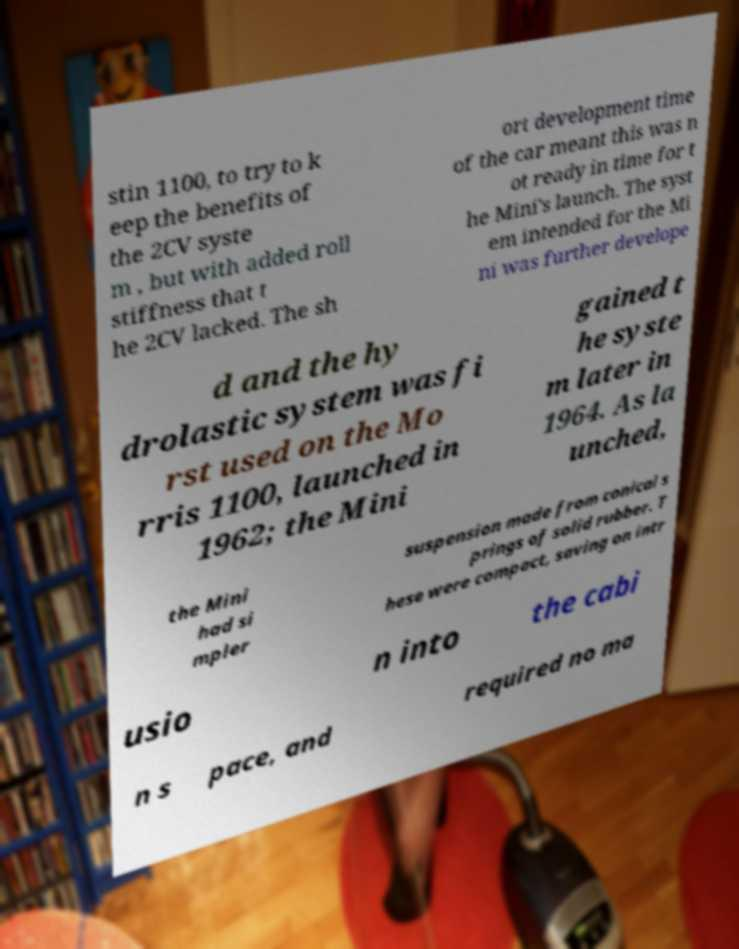There's text embedded in this image that I need extracted. Can you transcribe it verbatim? stin 1100, to try to k eep the benefits of the 2CV syste m , but with added roll stiffness that t he 2CV lacked. The sh ort development time of the car meant this was n ot ready in time for t he Mini's launch. The syst em intended for the Mi ni was further develope d and the hy drolastic system was fi rst used on the Mo rris 1100, launched in 1962; the Mini gained t he syste m later in 1964. As la unched, the Mini had si mpler suspension made from conical s prings of solid rubber. T hese were compact, saving on intr usio n into the cabi n s pace, and required no ma 